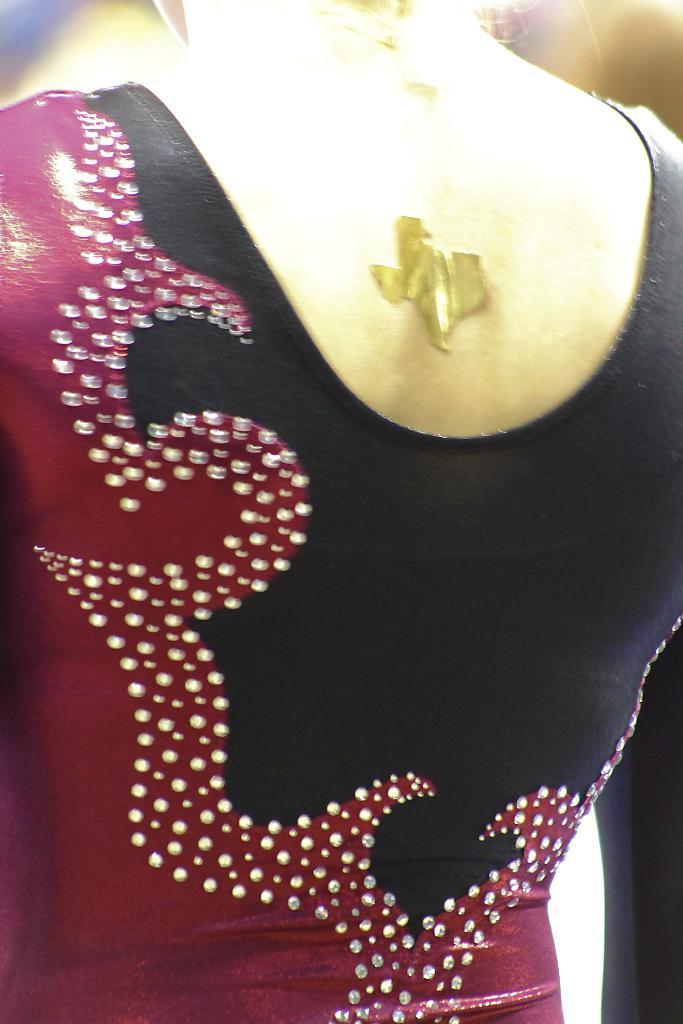What is the main subject of the image? There is a person in the image. Can you describe the person's position or orientation in the image? The person is facing away from the viewer. What type of crown is the person wearing in the image? There is no crown present in the image; the person is not wearing any headgear. What test is the person taking in the image? There is no test being taken in the image; the person is simply facing away from the viewer. 